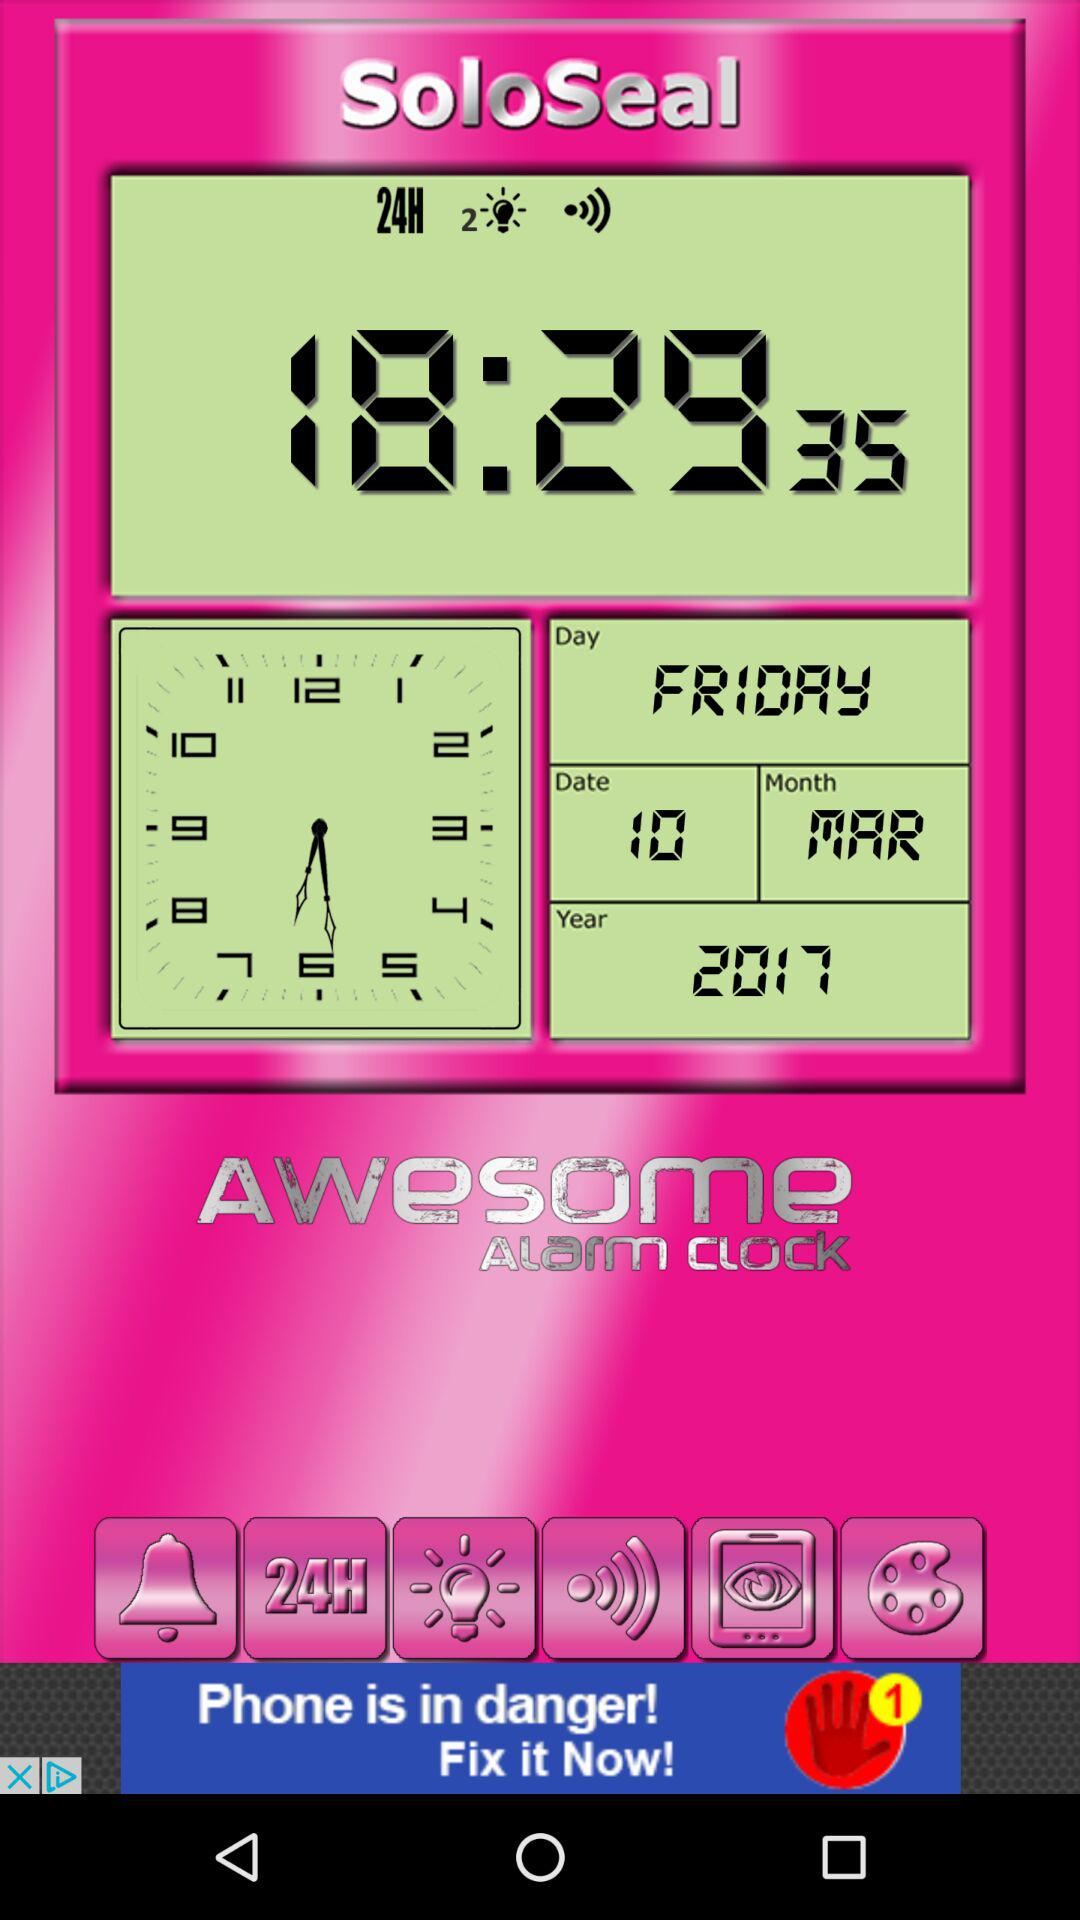What is the selected year? The selected year is 2017. 